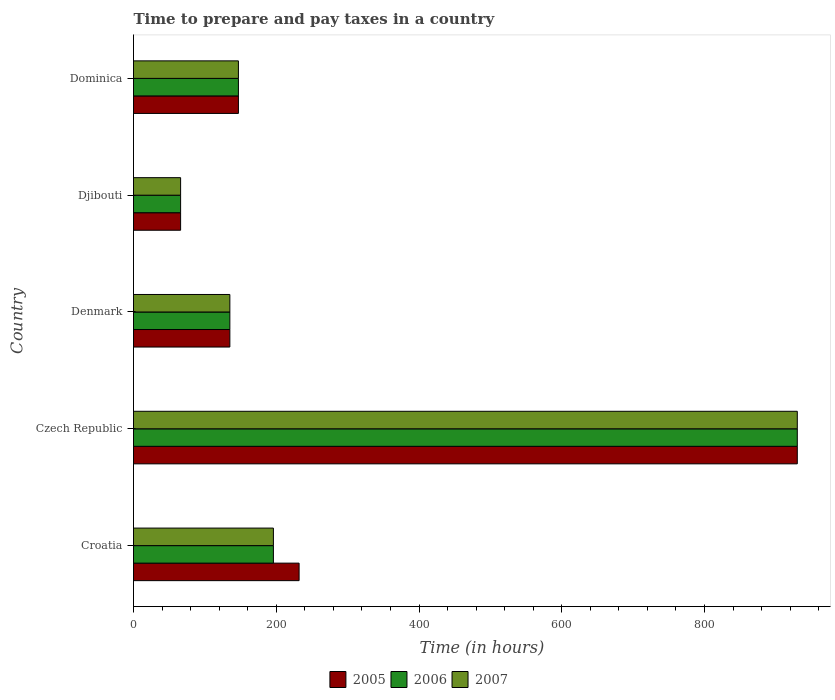How many different coloured bars are there?
Provide a short and direct response. 3. Are the number of bars per tick equal to the number of legend labels?
Offer a terse response. Yes. What is the label of the 1st group of bars from the top?
Your answer should be very brief. Dominica. In how many cases, is the number of bars for a given country not equal to the number of legend labels?
Provide a succinct answer. 0. What is the number of hours required to prepare and pay taxes in 2007 in Croatia?
Offer a terse response. 196. Across all countries, what is the maximum number of hours required to prepare and pay taxes in 2007?
Offer a very short reply. 930. In which country was the number of hours required to prepare and pay taxes in 2007 maximum?
Provide a succinct answer. Czech Republic. In which country was the number of hours required to prepare and pay taxes in 2005 minimum?
Keep it short and to the point. Djibouti. What is the total number of hours required to prepare and pay taxes in 2007 in the graph?
Your response must be concise. 1474. What is the difference between the number of hours required to prepare and pay taxes in 2006 in Croatia and that in Czech Republic?
Your answer should be very brief. -734. What is the difference between the number of hours required to prepare and pay taxes in 2005 in Djibouti and the number of hours required to prepare and pay taxes in 2007 in Czech Republic?
Provide a succinct answer. -864. What is the average number of hours required to prepare and pay taxes in 2007 per country?
Offer a terse response. 294.8. What is the difference between the number of hours required to prepare and pay taxes in 2007 and number of hours required to prepare and pay taxes in 2006 in Czech Republic?
Offer a very short reply. 0. In how many countries, is the number of hours required to prepare and pay taxes in 2006 greater than 160 hours?
Your answer should be very brief. 2. What is the ratio of the number of hours required to prepare and pay taxes in 2006 in Czech Republic to that in Denmark?
Your answer should be compact. 6.89. Is the number of hours required to prepare and pay taxes in 2005 in Croatia less than that in Dominica?
Your answer should be very brief. No. What is the difference between the highest and the second highest number of hours required to prepare and pay taxes in 2007?
Offer a terse response. 734. What is the difference between the highest and the lowest number of hours required to prepare and pay taxes in 2005?
Provide a succinct answer. 864. In how many countries, is the number of hours required to prepare and pay taxes in 2006 greater than the average number of hours required to prepare and pay taxes in 2006 taken over all countries?
Ensure brevity in your answer.  1. What does the 1st bar from the top in Czech Republic represents?
Provide a short and direct response. 2007. Are all the bars in the graph horizontal?
Your answer should be very brief. Yes. What is the difference between two consecutive major ticks on the X-axis?
Offer a terse response. 200. Does the graph contain any zero values?
Give a very brief answer. No. Does the graph contain grids?
Give a very brief answer. No. How many legend labels are there?
Your answer should be very brief. 3. What is the title of the graph?
Your response must be concise. Time to prepare and pay taxes in a country. Does "1969" appear as one of the legend labels in the graph?
Offer a very short reply. No. What is the label or title of the X-axis?
Keep it short and to the point. Time (in hours). What is the Time (in hours) of 2005 in Croatia?
Keep it short and to the point. 232. What is the Time (in hours) of 2006 in Croatia?
Your response must be concise. 196. What is the Time (in hours) in 2007 in Croatia?
Make the answer very short. 196. What is the Time (in hours) in 2005 in Czech Republic?
Provide a short and direct response. 930. What is the Time (in hours) of 2006 in Czech Republic?
Provide a short and direct response. 930. What is the Time (in hours) in 2007 in Czech Republic?
Your answer should be compact. 930. What is the Time (in hours) in 2005 in Denmark?
Provide a short and direct response. 135. What is the Time (in hours) of 2006 in Denmark?
Provide a short and direct response. 135. What is the Time (in hours) of 2007 in Denmark?
Offer a terse response. 135. What is the Time (in hours) in 2005 in Djibouti?
Ensure brevity in your answer.  66. What is the Time (in hours) in 2007 in Djibouti?
Provide a succinct answer. 66. What is the Time (in hours) of 2005 in Dominica?
Make the answer very short. 147. What is the Time (in hours) of 2006 in Dominica?
Offer a very short reply. 147. What is the Time (in hours) of 2007 in Dominica?
Make the answer very short. 147. Across all countries, what is the maximum Time (in hours) of 2005?
Your answer should be very brief. 930. Across all countries, what is the maximum Time (in hours) in 2006?
Make the answer very short. 930. Across all countries, what is the maximum Time (in hours) in 2007?
Your answer should be compact. 930. Across all countries, what is the minimum Time (in hours) of 2006?
Give a very brief answer. 66. What is the total Time (in hours) of 2005 in the graph?
Make the answer very short. 1510. What is the total Time (in hours) in 2006 in the graph?
Offer a terse response. 1474. What is the total Time (in hours) in 2007 in the graph?
Provide a short and direct response. 1474. What is the difference between the Time (in hours) of 2005 in Croatia and that in Czech Republic?
Provide a succinct answer. -698. What is the difference between the Time (in hours) of 2006 in Croatia and that in Czech Republic?
Your answer should be very brief. -734. What is the difference between the Time (in hours) in 2007 in Croatia and that in Czech Republic?
Keep it short and to the point. -734. What is the difference between the Time (in hours) in 2005 in Croatia and that in Denmark?
Ensure brevity in your answer.  97. What is the difference between the Time (in hours) in 2006 in Croatia and that in Denmark?
Offer a very short reply. 61. What is the difference between the Time (in hours) of 2007 in Croatia and that in Denmark?
Ensure brevity in your answer.  61. What is the difference between the Time (in hours) of 2005 in Croatia and that in Djibouti?
Your response must be concise. 166. What is the difference between the Time (in hours) of 2006 in Croatia and that in Djibouti?
Keep it short and to the point. 130. What is the difference between the Time (in hours) in 2007 in Croatia and that in Djibouti?
Your answer should be very brief. 130. What is the difference between the Time (in hours) in 2005 in Croatia and that in Dominica?
Offer a very short reply. 85. What is the difference between the Time (in hours) of 2007 in Croatia and that in Dominica?
Offer a very short reply. 49. What is the difference between the Time (in hours) in 2005 in Czech Republic and that in Denmark?
Ensure brevity in your answer.  795. What is the difference between the Time (in hours) in 2006 in Czech Republic and that in Denmark?
Offer a very short reply. 795. What is the difference between the Time (in hours) in 2007 in Czech Republic and that in Denmark?
Keep it short and to the point. 795. What is the difference between the Time (in hours) in 2005 in Czech Republic and that in Djibouti?
Your answer should be compact. 864. What is the difference between the Time (in hours) of 2006 in Czech Republic and that in Djibouti?
Make the answer very short. 864. What is the difference between the Time (in hours) of 2007 in Czech Republic and that in Djibouti?
Provide a short and direct response. 864. What is the difference between the Time (in hours) of 2005 in Czech Republic and that in Dominica?
Ensure brevity in your answer.  783. What is the difference between the Time (in hours) of 2006 in Czech Republic and that in Dominica?
Offer a terse response. 783. What is the difference between the Time (in hours) in 2007 in Czech Republic and that in Dominica?
Provide a succinct answer. 783. What is the difference between the Time (in hours) in 2005 in Denmark and that in Djibouti?
Give a very brief answer. 69. What is the difference between the Time (in hours) of 2006 in Denmark and that in Djibouti?
Ensure brevity in your answer.  69. What is the difference between the Time (in hours) of 2005 in Denmark and that in Dominica?
Your answer should be compact. -12. What is the difference between the Time (in hours) in 2006 in Denmark and that in Dominica?
Keep it short and to the point. -12. What is the difference between the Time (in hours) of 2007 in Denmark and that in Dominica?
Offer a very short reply. -12. What is the difference between the Time (in hours) in 2005 in Djibouti and that in Dominica?
Keep it short and to the point. -81. What is the difference between the Time (in hours) of 2006 in Djibouti and that in Dominica?
Provide a short and direct response. -81. What is the difference between the Time (in hours) in 2007 in Djibouti and that in Dominica?
Ensure brevity in your answer.  -81. What is the difference between the Time (in hours) in 2005 in Croatia and the Time (in hours) in 2006 in Czech Republic?
Offer a very short reply. -698. What is the difference between the Time (in hours) of 2005 in Croatia and the Time (in hours) of 2007 in Czech Republic?
Your response must be concise. -698. What is the difference between the Time (in hours) in 2006 in Croatia and the Time (in hours) in 2007 in Czech Republic?
Provide a succinct answer. -734. What is the difference between the Time (in hours) in 2005 in Croatia and the Time (in hours) in 2006 in Denmark?
Give a very brief answer. 97. What is the difference between the Time (in hours) of 2005 in Croatia and the Time (in hours) of 2007 in Denmark?
Provide a succinct answer. 97. What is the difference between the Time (in hours) of 2005 in Croatia and the Time (in hours) of 2006 in Djibouti?
Keep it short and to the point. 166. What is the difference between the Time (in hours) of 2005 in Croatia and the Time (in hours) of 2007 in Djibouti?
Ensure brevity in your answer.  166. What is the difference between the Time (in hours) in 2006 in Croatia and the Time (in hours) in 2007 in Djibouti?
Provide a short and direct response. 130. What is the difference between the Time (in hours) of 2005 in Croatia and the Time (in hours) of 2007 in Dominica?
Provide a short and direct response. 85. What is the difference between the Time (in hours) in 2006 in Croatia and the Time (in hours) in 2007 in Dominica?
Offer a terse response. 49. What is the difference between the Time (in hours) in 2005 in Czech Republic and the Time (in hours) in 2006 in Denmark?
Make the answer very short. 795. What is the difference between the Time (in hours) of 2005 in Czech Republic and the Time (in hours) of 2007 in Denmark?
Ensure brevity in your answer.  795. What is the difference between the Time (in hours) of 2006 in Czech Republic and the Time (in hours) of 2007 in Denmark?
Make the answer very short. 795. What is the difference between the Time (in hours) of 2005 in Czech Republic and the Time (in hours) of 2006 in Djibouti?
Provide a short and direct response. 864. What is the difference between the Time (in hours) of 2005 in Czech Republic and the Time (in hours) of 2007 in Djibouti?
Your response must be concise. 864. What is the difference between the Time (in hours) in 2006 in Czech Republic and the Time (in hours) in 2007 in Djibouti?
Provide a succinct answer. 864. What is the difference between the Time (in hours) of 2005 in Czech Republic and the Time (in hours) of 2006 in Dominica?
Your answer should be very brief. 783. What is the difference between the Time (in hours) in 2005 in Czech Republic and the Time (in hours) in 2007 in Dominica?
Keep it short and to the point. 783. What is the difference between the Time (in hours) in 2006 in Czech Republic and the Time (in hours) in 2007 in Dominica?
Give a very brief answer. 783. What is the difference between the Time (in hours) in 2005 in Denmark and the Time (in hours) in 2007 in Djibouti?
Ensure brevity in your answer.  69. What is the difference between the Time (in hours) in 2005 in Denmark and the Time (in hours) in 2007 in Dominica?
Your answer should be very brief. -12. What is the difference between the Time (in hours) in 2005 in Djibouti and the Time (in hours) in 2006 in Dominica?
Your response must be concise. -81. What is the difference between the Time (in hours) of 2005 in Djibouti and the Time (in hours) of 2007 in Dominica?
Offer a very short reply. -81. What is the difference between the Time (in hours) of 2006 in Djibouti and the Time (in hours) of 2007 in Dominica?
Make the answer very short. -81. What is the average Time (in hours) of 2005 per country?
Provide a succinct answer. 302. What is the average Time (in hours) in 2006 per country?
Give a very brief answer. 294.8. What is the average Time (in hours) in 2007 per country?
Offer a very short reply. 294.8. What is the difference between the Time (in hours) in 2005 and Time (in hours) in 2006 in Croatia?
Keep it short and to the point. 36. What is the difference between the Time (in hours) of 2006 and Time (in hours) of 2007 in Croatia?
Offer a terse response. 0. What is the difference between the Time (in hours) of 2006 and Time (in hours) of 2007 in Czech Republic?
Offer a terse response. 0. What is the difference between the Time (in hours) in 2005 and Time (in hours) in 2007 in Denmark?
Ensure brevity in your answer.  0. What is the difference between the Time (in hours) in 2006 and Time (in hours) in 2007 in Denmark?
Make the answer very short. 0. What is the difference between the Time (in hours) in 2005 and Time (in hours) in 2006 in Djibouti?
Offer a very short reply. 0. What is the difference between the Time (in hours) in 2005 and Time (in hours) in 2007 in Djibouti?
Your answer should be very brief. 0. What is the difference between the Time (in hours) of 2005 and Time (in hours) of 2006 in Dominica?
Keep it short and to the point. 0. What is the difference between the Time (in hours) in 2006 and Time (in hours) in 2007 in Dominica?
Provide a succinct answer. 0. What is the ratio of the Time (in hours) of 2005 in Croatia to that in Czech Republic?
Ensure brevity in your answer.  0.25. What is the ratio of the Time (in hours) of 2006 in Croatia to that in Czech Republic?
Your response must be concise. 0.21. What is the ratio of the Time (in hours) in 2007 in Croatia to that in Czech Republic?
Make the answer very short. 0.21. What is the ratio of the Time (in hours) of 2005 in Croatia to that in Denmark?
Provide a succinct answer. 1.72. What is the ratio of the Time (in hours) in 2006 in Croatia to that in Denmark?
Provide a succinct answer. 1.45. What is the ratio of the Time (in hours) of 2007 in Croatia to that in Denmark?
Provide a short and direct response. 1.45. What is the ratio of the Time (in hours) in 2005 in Croatia to that in Djibouti?
Keep it short and to the point. 3.52. What is the ratio of the Time (in hours) in 2006 in Croatia to that in Djibouti?
Provide a succinct answer. 2.97. What is the ratio of the Time (in hours) of 2007 in Croatia to that in Djibouti?
Ensure brevity in your answer.  2.97. What is the ratio of the Time (in hours) of 2005 in Croatia to that in Dominica?
Provide a succinct answer. 1.58. What is the ratio of the Time (in hours) in 2007 in Croatia to that in Dominica?
Keep it short and to the point. 1.33. What is the ratio of the Time (in hours) of 2005 in Czech Republic to that in Denmark?
Your answer should be compact. 6.89. What is the ratio of the Time (in hours) of 2006 in Czech Republic to that in Denmark?
Ensure brevity in your answer.  6.89. What is the ratio of the Time (in hours) in 2007 in Czech Republic to that in Denmark?
Offer a very short reply. 6.89. What is the ratio of the Time (in hours) in 2005 in Czech Republic to that in Djibouti?
Provide a short and direct response. 14.09. What is the ratio of the Time (in hours) of 2006 in Czech Republic to that in Djibouti?
Offer a terse response. 14.09. What is the ratio of the Time (in hours) in 2007 in Czech Republic to that in Djibouti?
Keep it short and to the point. 14.09. What is the ratio of the Time (in hours) of 2005 in Czech Republic to that in Dominica?
Make the answer very short. 6.33. What is the ratio of the Time (in hours) in 2006 in Czech Republic to that in Dominica?
Your answer should be compact. 6.33. What is the ratio of the Time (in hours) of 2007 in Czech Republic to that in Dominica?
Make the answer very short. 6.33. What is the ratio of the Time (in hours) in 2005 in Denmark to that in Djibouti?
Ensure brevity in your answer.  2.05. What is the ratio of the Time (in hours) in 2006 in Denmark to that in Djibouti?
Your answer should be compact. 2.05. What is the ratio of the Time (in hours) in 2007 in Denmark to that in Djibouti?
Give a very brief answer. 2.05. What is the ratio of the Time (in hours) of 2005 in Denmark to that in Dominica?
Your answer should be compact. 0.92. What is the ratio of the Time (in hours) in 2006 in Denmark to that in Dominica?
Your response must be concise. 0.92. What is the ratio of the Time (in hours) of 2007 in Denmark to that in Dominica?
Offer a terse response. 0.92. What is the ratio of the Time (in hours) in 2005 in Djibouti to that in Dominica?
Provide a succinct answer. 0.45. What is the ratio of the Time (in hours) in 2006 in Djibouti to that in Dominica?
Offer a terse response. 0.45. What is the ratio of the Time (in hours) in 2007 in Djibouti to that in Dominica?
Your response must be concise. 0.45. What is the difference between the highest and the second highest Time (in hours) of 2005?
Your answer should be very brief. 698. What is the difference between the highest and the second highest Time (in hours) in 2006?
Offer a very short reply. 734. What is the difference between the highest and the second highest Time (in hours) of 2007?
Ensure brevity in your answer.  734. What is the difference between the highest and the lowest Time (in hours) in 2005?
Make the answer very short. 864. What is the difference between the highest and the lowest Time (in hours) of 2006?
Make the answer very short. 864. What is the difference between the highest and the lowest Time (in hours) in 2007?
Provide a short and direct response. 864. 